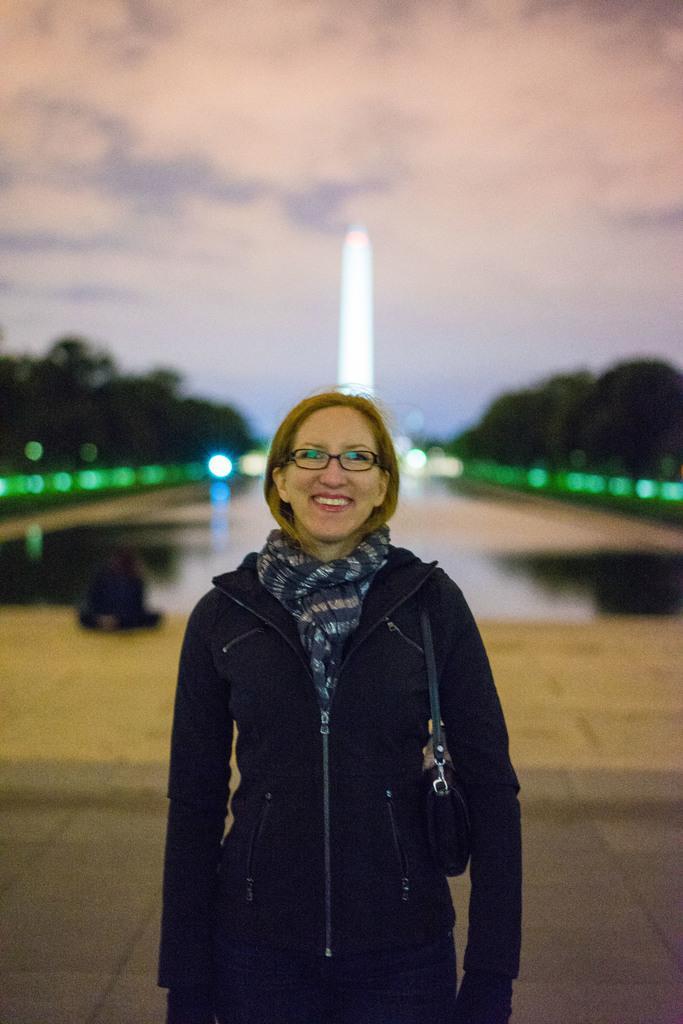Please provide a concise description of this image. In this picture, there is a woman in the center. She is wearing a black jacket, scarf and carrying a bag. In the background, there are trees and sky. 